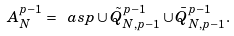Convert formula to latex. <formula><loc_0><loc_0><loc_500><loc_500>A _ { N } ^ { p - 1 } = \ a s p \cup \tilde { Q } _ { N , p - 1 } ^ { p - 1 } \cup \bar { Q } _ { N , p - 1 } ^ { p - 1 } .</formula> 